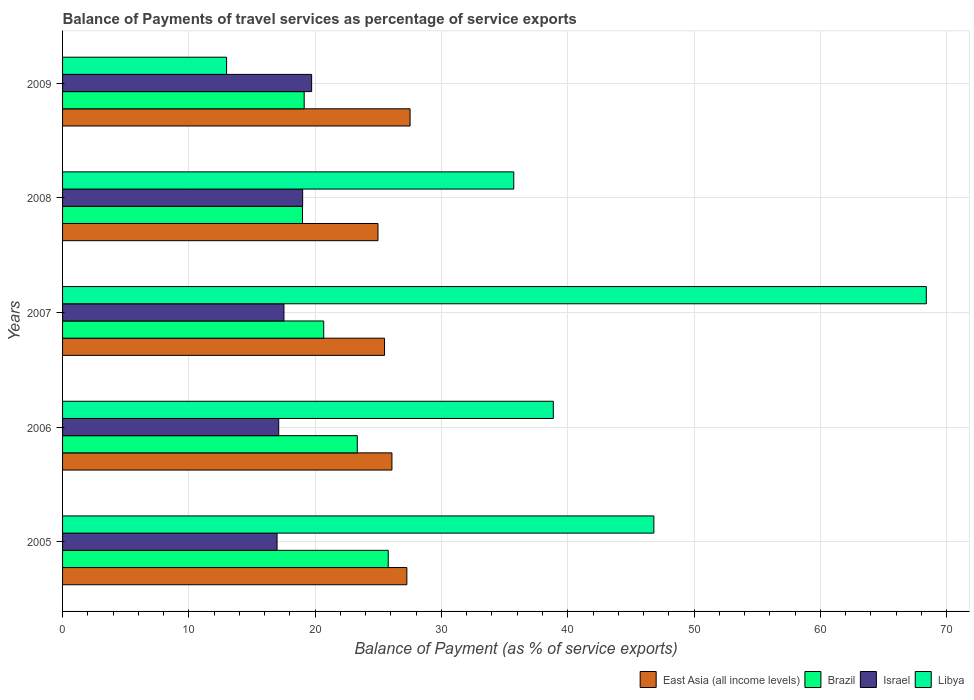How many different coloured bars are there?
Give a very brief answer. 4. How many groups of bars are there?
Provide a succinct answer. 5. Are the number of bars per tick equal to the number of legend labels?
Make the answer very short. Yes. How many bars are there on the 2nd tick from the top?
Ensure brevity in your answer.  4. How many bars are there on the 2nd tick from the bottom?
Offer a very short reply. 4. What is the label of the 2nd group of bars from the top?
Offer a terse response. 2008. In how many cases, is the number of bars for a given year not equal to the number of legend labels?
Offer a terse response. 0. What is the balance of payments of travel services in Brazil in 2007?
Make the answer very short. 20.68. Across all years, what is the maximum balance of payments of travel services in Libya?
Keep it short and to the point. 68.39. Across all years, what is the minimum balance of payments of travel services in Israel?
Your answer should be very brief. 16.98. What is the total balance of payments of travel services in Libya in the graph?
Your answer should be very brief. 202.77. What is the difference between the balance of payments of travel services in Israel in 2005 and that in 2009?
Provide a short and direct response. -2.74. What is the difference between the balance of payments of travel services in Israel in 2006 and the balance of payments of travel services in East Asia (all income levels) in 2009?
Provide a short and direct response. -10.4. What is the average balance of payments of travel services in Israel per year?
Make the answer very short. 18.07. In the year 2009, what is the difference between the balance of payments of travel services in East Asia (all income levels) and balance of payments of travel services in Israel?
Ensure brevity in your answer.  7.79. What is the ratio of the balance of payments of travel services in Israel in 2008 to that in 2009?
Offer a terse response. 0.96. Is the balance of payments of travel services in Libya in 2006 less than that in 2009?
Provide a short and direct response. No. What is the difference between the highest and the second highest balance of payments of travel services in East Asia (all income levels)?
Offer a very short reply. 0.25. What is the difference between the highest and the lowest balance of payments of travel services in Libya?
Keep it short and to the point. 55.4. In how many years, is the balance of payments of travel services in Israel greater than the average balance of payments of travel services in Israel taken over all years?
Provide a short and direct response. 2. Is the sum of the balance of payments of travel services in Libya in 2008 and 2009 greater than the maximum balance of payments of travel services in Israel across all years?
Your answer should be very brief. Yes. What does the 2nd bar from the top in 2007 represents?
Offer a very short reply. Israel. What does the 3rd bar from the bottom in 2008 represents?
Give a very brief answer. Israel. Is it the case that in every year, the sum of the balance of payments of travel services in Israel and balance of payments of travel services in Brazil is greater than the balance of payments of travel services in Libya?
Provide a succinct answer. No. Does the graph contain grids?
Make the answer very short. Yes. How many legend labels are there?
Offer a very short reply. 4. How are the legend labels stacked?
Offer a very short reply. Horizontal. What is the title of the graph?
Your answer should be compact. Balance of Payments of travel services as percentage of service exports. Does "Heavily indebted poor countries" appear as one of the legend labels in the graph?
Make the answer very short. No. What is the label or title of the X-axis?
Your answer should be compact. Balance of Payment (as % of service exports). What is the Balance of Payment (as % of service exports) of East Asia (all income levels) in 2005?
Offer a terse response. 27.26. What is the Balance of Payment (as % of service exports) of Brazil in 2005?
Provide a short and direct response. 25.78. What is the Balance of Payment (as % of service exports) of Israel in 2005?
Provide a short and direct response. 16.98. What is the Balance of Payment (as % of service exports) in Libya in 2005?
Your answer should be very brief. 46.82. What is the Balance of Payment (as % of service exports) in East Asia (all income levels) in 2006?
Provide a succinct answer. 26.08. What is the Balance of Payment (as % of service exports) of Brazil in 2006?
Ensure brevity in your answer.  23.34. What is the Balance of Payment (as % of service exports) in Israel in 2006?
Provide a short and direct response. 17.11. What is the Balance of Payment (as % of service exports) in Libya in 2006?
Offer a terse response. 38.85. What is the Balance of Payment (as % of service exports) in East Asia (all income levels) in 2007?
Offer a very short reply. 25.49. What is the Balance of Payment (as % of service exports) in Brazil in 2007?
Your answer should be very brief. 20.68. What is the Balance of Payment (as % of service exports) of Israel in 2007?
Your response must be concise. 17.53. What is the Balance of Payment (as % of service exports) in Libya in 2007?
Keep it short and to the point. 68.39. What is the Balance of Payment (as % of service exports) of East Asia (all income levels) in 2008?
Your response must be concise. 24.97. What is the Balance of Payment (as % of service exports) in Brazil in 2008?
Your answer should be very brief. 19. What is the Balance of Payment (as % of service exports) in Israel in 2008?
Your answer should be very brief. 19.01. What is the Balance of Payment (as % of service exports) in Libya in 2008?
Make the answer very short. 35.72. What is the Balance of Payment (as % of service exports) of East Asia (all income levels) in 2009?
Provide a short and direct response. 27.51. What is the Balance of Payment (as % of service exports) of Brazil in 2009?
Make the answer very short. 19.13. What is the Balance of Payment (as % of service exports) in Israel in 2009?
Provide a succinct answer. 19.72. What is the Balance of Payment (as % of service exports) in Libya in 2009?
Provide a short and direct response. 12.99. Across all years, what is the maximum Balance of Payment (as % of service exports) in East Asia (all income levels)?
Offer a very short reply. 27.51. Across all years, what is the maximum Balance of Payment (as % of service exports) of Brazil?
Provide a succinct answer. 25.78. Across all years, what is the maximum Balance of Payment (as % of service exports) of Israel?
Your answer should be compact. 19.72. Across all years, what is the maximum Balance of Payment (as % of service exports) in Libya?
Offer a terse response. 68.39. Across all years, what is the minimum Balance of Payment (as % of service exports) of East Asia (all income levels)?
Keep it short and to the point. 24.97. Across all years, what is the minimum Balance of Payment (as % of service exports) of Brazil?
Provide a short and direct response. 19. Across all years, what is the minimum Balance of Payment (as % of service exports) in Israel?
Give a very brief answer. 16.98. Across all years, what is the minimum Balance of Payment (as % of service exports) in Libya?
Provide a short and direct response. 12.99. What is the total Balance of Payment (as % of service exports) in East Asia (all income levels) in the graph?
Provide a short and direct response. 131.32. What is the total Balance of Payment (as % of service exports) in Brazil in the graph?
Make the answer very short. 107.93. What is the total Balance of Payment (as % of service exports) of Israel in the graph?
Provide a succinct answer. 90.35. What is the total Balance of Payment (as % of service exports) in Libya in the graph?
Keep it short and to the point. 202.77. What is the difference between the Balance of Payment (as % of service exports) of East Asia (all income levels) in 2005 and that in 2006?
Your response must be concise. 1.18. What is the difference between the Balance of Payment (as % of service exports) in Brazil in 2005 and that in 2006?
Offer a very short reply. 2.45. What is the difference between the Balance of Payment (as % of service exports) of Israel in 2005 and that in 2006?
Offer a terse response. -0.13. What is the difference between the Balance of Payment (as % of service exports) in Libya in 2005 and that in 2006?
Give a very brief answer. 7.96. What is the difference between the Balance of Payment (as % of service exports) in East Asia (all income levels) in 2005 and that in 2007?
Provide a short and direct response. 1.77. What is the difference between the Balance of Payment (as % of service exports) of Brazil in 2005 and that in 2007?
Provide a short and direct response. 5.11. What is the difference between the Balance of Payment (as % of service exports) of Israel in 2005 and that in 2007?
Your response must be concise. -0.55. What is the difference between the Balance of Payment (as % of service exports) of Libya in 2005 and that in 2007?
Your response must be concise. -21.57. What is the difference between the Balance of Payment (as % of service exports) of East Asia (all income levels) in 2005 and that in 2008?
Your response must be concise. 2.29. What is the difference between the Balance of Payment (as % of service exports) of Brazil in 2005 and that in 2008?
Your answer should be compact. 6.79. What is the difference between the Balance of Payment (as % of service exports) of Israel in 2005 and that in 2008?
Your answer should be compact. -2.03. What is the difference between the Balance of Payment (as % of service exports) of Libya in 2005 and that in 2008?
Make the answer very short. 11.09. What is the difference between the Balance of Payment (as % of service exports) of East Asia (all income levels) in 2005 and that in 2009?
Ensure brevity in your answer.  -0.25. What is the difference between the Balance of Payment (as % of service exports) in Brazil in 2005 and that in 2009?
Offer a very short reply. 6.65. What is the difference between the Balance of Payment (as % of service exports) in Israel in 2005 and that in 2009?
Give a very brief answer. -2.74. What is the difference between the Balance of Payment (as % of service exports) of Libya in 2005 and that in 2009?
Ensure brevity in your answer.  33.83. What is the difference between the Balance of Payment (as % of service exports) of East Asia (all income levels) in 2006 and that in 2007?
Provide a short and direct response. 0.59. What is the difference between the Balance of Payment (as % of service exports) of Brazil in 2006 and that in 2007?
Make the answer very short. 2.66. What is the difference between the Balance of Payment (as % of service exports) in Israel in 2006 and that in 2007?
Keep it short and to the point. -0.42. What is the difference between the Balance of Payment (as % of service exports) in Libya in 2006 and that in 2007?
Provide a succinct answer. -29.53. What is the difference between the Balance of Payment (as % of service exports) of East Asia (all income levels) in 2006 and that in 2008?
Give a very brief answer. 1.1. What is the difference between the Balance of Payment (as % of service exports) of Brazil in 2006 and that in 2008?
Your answer should be compact. 4.34. What is the difference between the Balance of Payment (as % of service exports) in Israel in 2006 and that in 2008?
Your answer should be compact. -1.9. What is the difference between the Balance of Payment (as % of service exports) in Libya in 2006 and that in 2008?
Give a very brief answer. 3.13. What is the difference between the Balance of Payment (as % of service exports) of East Asia (all income levels) in 2006 and that in 2009?
Provide a short and direct response. -1.44. What is the difference between the Balance of Payment (as % of service exports) in Brazil in 2006 and that in 2009?
Ensure brevity in your answer.  4.2. What is the difference between the Balance of Payment (as % of service exports) in Israel in 2006 and that in 2009?
Ensure brevity in your answer.  -2.61. What is the difference between the Balance of Payment (as % of service exports) in Libya in 2006 and that in 2009?
Provide a short and direct response. 25.87. What is the difference between the Balance of Payment (as % of service exports) in East Asia (all income levels) in 2007 and that in 2008?
Your answer should be compact. 0.52. What is the difference between the Balance of Payment (as % of service exports) in Brazil in 2007 and that in 2008?
Provide a succinct answer. 1.68. What is the difference between the Balance of Payment (as % of service exports) in Israel in 2007 and that in 2008?
Keep it short and to the point. -1.48. What is the difference between the Balance of Payment (as % of service exports) in Libya in 2007 and that in 2008?
Provide a short and direct response. 32.66. What is the difference between the Balance of Payment (as % of service exports) in East Asia (all income levels) in 2007 and that in 2009?
Your answer should be compact. -2.02. What is the difference between the Balance of Payment (as % of service exports) in Brazil in 2007 and that in 2009?
Ensure brevity in your answer.  1.55. What is the difference between the Balance of Payment (as % of service exports) of Israel in 2007 and that in 2009?
Your answer should be very brief. -2.19. What is the difference between the Balance of Payment (as % of service exports) of Libya in 2007 and that in 2009?
Your answer should be compact. 55.4. What is the difference between the Balance of Payment (as % of service exports) of East Asia (all income levels) in 2008 and that in 2009?
Your answer should be very brief. -2.54. What is the difference between the Balance of Payment (as % of service exports) of Brazil in 2008 and that in 2009?
Offer a very short reply. -0.13. What is the difference between the Balance of Payment (as % of service exports) in Israel in 2008 and that in 2009?
Your response must be concise. -0.71. What is the difference between the Balance of Payment (as % of service exports) in Libya in 2008 and that in 2009?
Provide a short and direct response. 22.74. What is the difference between the Balance of Payment (as % of service exports) in East Asia (all income levels) in 2005 and the Balance of Payment (as % of service exports) in Brazil in 2006?
Give a very brief answer. 3.92. What is the difference between the Balance of Payment (as % of service exports) in East Asia (all income levels) in 2005 and the Balance of Payment (as % of service exports) in Israel in 2006?
Keep it short and to the point. 10.15. What is the difference between the Balance of Payment (as % of service exports) in East Asia (all income levels) in 2005 and the Balance of Payment (as % of service exports) in Libya in 2006?
Your response must be concise. -11.59. What is the difference between the Balance of Payment (as % of service exports) of Brazil in 2005 and the Balance of Payment (as % of service exports) of Israel in 2006?
Keep it short and to the point. 8.67. What is the difference between the Balance of Payment (as % of service exports) in Brazil in 2005 and the Balance of Payment (as % of service exports) in Libya in 2006?
Your answer should be compact. -13.07. What is the difference between the Balance of Payment (as % of service exports) in Israel in 2005 and the Balance of Payment (as % of service exports) in Libya in 2006?
Ensure brevity in your answer.  -21.87. What is the difference between the Balance of Payment (as % of service exports) of East Asia (all income levels) in 2005 and the Balance of Payment (as % of service exports) of Brazil in 2007?
Make the answer very short. 6.58. What is the difference between the Balance of Payment (as % of service exports) in East Asia (all income levels) in 2005 and the Balance of Payment (as % of service exports) in Israel in 2007?
Provide a short and direct response. 9.73. What is the difference between the Balance of Payment (as % of service exports) in East Asia (all income levels) in 2005 and the Balance of Payment (as % of service exports) in Libya in 2007?
Provide a succinct answer. -41.13. What is the difference between the Balance of Payment (as % of service exports) of Brazil in 2005 and the Balance of Payment (as % of service exports) of Israel in 2007?
Offer a terse response. 8.26. What is the difference between the Balance of Payment (as % of service exports) of Brazil in 2005 and the Balance of Payment (as % of service exports) of Libya in 2007?
Ensure brevity in your answer.  -42.6. What is the difference between the Balance of Payment (as % of service exports) in Israel in 2005 and the Balance of Payment (as % of service exports) in Libya in 2007?
Your answer should be very brief. -51.4. What is the difference between the Balance of Payment (as % of service exports) of East Asia (all income levels) in 2005 and the Balance of Payment (as % of service exports) of Brazil in 2008?
Give a very brief answer. 8.26. What is the difference between the Balance of Payment (as % of service exports) in East Asia (all income levels) in 2005 and the Balance of Payment (as % of service exports) in Israel in 2008?
Provide a succinct answer. 8.25. What is the difference between the Balance of Payment (as % of service exports) in East Asia (all income levels) in 2005 and the Balance of Payment (as % of service exports) in Libya in 2008?
Make the answer very short. -8.46. What is the difference between the Balance of Payment (as % of service exports) in Brazil in 2005 and the Balance of Payment (as % of service exports) in Israel in 2008?
Give a very brief answer. 6.78. What is the difference between the Balance of Payment (as % of service exports) in Brazil in 2005 and the Balance of Payment (as % of service exports) in Libya in 2008?
Your response must be concise. -9.94. What is the difference between the Balance of Payment (as % of service exports) in Israel in 2005 and the Balance of Payment (as % of service exports) in Libya in 2008?
Provide a succinct answer. -18.74. What is the difference between the Balance of Payment (as % of service exports) in East Asia (all income levels) in 2005 and the Balance of Payment (as % of service exports) in Brazil in 2009?
Your response must be concise. 8.13. What is the difference between the Balance of Payment (as % of service exports) in East Asia (all income levels) in 2005 and the Balance of Payment (as % of service exports) in Israel in 2009?
Provide a succinct answer. 7.54. What is the difference between the Balance of Payment (as % of service exports) of East Asia (all income levels) in 2005 and the Balance of Payment (as % of service exports) of Libya in 2009?
Your answer should be compact. 14.27. What is the difference between the Balance of Payment (as % of service exports) in Brazil in 2005 and the Balance of Payment (as % of service exports) in Israel in 2009?
Provide a succinct answer. 6.06. What is the difference between the Balance of Payment (as % of service exports) in Brazil in 2005 and the Balance of Payment (as % of service exports) in Libya in 2009?
Make the answer very short. 12.8. What is the difference between the Balance of Payment (as % of service exports) in Israel in 2005 and the Balance of Payment (as % of service exports) in Libya in 2009?
Your answer should be compact. 4. What is the difference between the Balance of Payment (as % of service exports) of East Asia (all income levels) in 2006 and the Balance of Payment (as % of service exports) of Brazil in 2007?
Make the answer very short. 5.4. What is the difference between the Balance of Payment (as % of service exports) of East Asia (all income levels) in 2006 and the Balance of Payment (as % of service exports) of Israel in 2007?
Your answer should be very brief. 8.55. What is the difference between the Balance of Payment (as % of service exports) in East Asia (all income levels) in 2006 and the Balance of Payment (as % of service exports) in Libya in 2007?
Provide a succinct answer. -42.31. What is the difference between the Balance of Payment (as % of service exports) in Brazil in 2006 and the Balance of Payment (as % of service exports) in Israel in 2007?
Offer a terse response. 5.81. What is the difference between the Balance of Payment (as % of service exports) of Brazil in 2006 and the Balance of Payment (as % of service exports) of Libya in 2007?
Make the answer very short. -45.05. What is the difference between the Balance of Payment (as % of service exports) in Israel in 2006 and the Balance of Payment (as % of service exports) in Libya in 2007?
Your answer should be compact. -51.27. What is the difference between the Balance of Payment (as % of service exports) of East Asia (all income levels) in 2006 and the Balance of Payment (as % of service exports) of Brazil in 2008?
Offer a terse response. 7.08. What is the difference between the Balance of Payment (as % of service exports) of East Asia (all income levels) in 2006 and the Balance of Payment (as % of service exports) of Israel in 2008?
Ensure brevity in your answer.  7.07. What is the difference between the Balance of Payment (as % of service exports) of East Asia (all income levels) in 2006 and the Balance of Payment (as % of service exports) of Libya in 2008?
Give a very brief answer. -9.65. What is the difference between the Balance of Payment (as % of service exports) in Brazil in 2006 and the Balance of Payment (as % of service exports) in Israel in 2008?
Provide a succinct answer. 4.33. What is the difference between the Balance of Payment (as % of service exports) of Brazil in 2006 and the Balance of Payment (as % of service exports) of Libya in 2008?
Your answer should be compact. -12.39. What is the difference between the Balance of Payment (as % of service exports) of Israel in 2006 and the Balance of Payment (as % of service exports) of Libya in 2008?
Your answer should be very brief. -18.61. What is the difference between the Balance of Payment (as % of service exports) in East Asia (all income levels) in 2006 and the Balance of Payment (as % of service exports) in Brazil in 2009?
Offer a terse response. 6.95. What is the difference between the Balance of Payment (as % of service exports) of East Asia (all income levels) in 2006 and the Balance of Payment (as % of service exports) of Israel in 2009?
Your response must be concise. 6.36. What is the difference between the Balance of Payment (as % of service exports) in East Asia (all income levels) in 2006 and the Balance of Payment (as % of service exports) in Libya in 2009?
Provide a succinct answer. 13.09. What is the difference between the Balance of Payment (as % of service exports) in Brazil in 2006 and the Balance of Payment (as % of service exports) in Israel in 2009?
Your response must be concise. 3.61. What is the difference between the Balance of Payment (as % of service exports) in Brazil in 2006 and the Balance of Payment (as % of service exports) in Libya in 2009?
Make the answer very short. 10.35. What is the difference between the Balance of Payment (as % of service exports) in Israel in 2006 and the Balance of Payment (as % of service exports) in Libya in 2009?
Your response must be concise. 4.13. What is the difference between the Balance of Payment (as % of service exports) of East Asia (all income levels) in 2007 and the Balance of Payment (as % of service exports) of Brazil in 2008?
Your response must be concise. 6.49. What is the difference between the Balance of Payment (as % of service exports) in East Asia (all income levels) in 2007 and the Balance of Payment (as % of service exports) in Israel in 2008?
Provide a succinct answer. 6.48. What is the difference between the Balance of Payment (as % of service exports) of East Asia (all income levels) in 2007 and the Balance of Payment (as % of service exports) of Libya in 2008?
Provide a succinct answer. -10.23. What is the difference between the Balance of Payment (as % of service exports) in Brazil in 2007 and the Balance of Payment (as % of service exports) in Israel in 2008?
Provide a short and direct response. 1.67. What is the difference between the Balance of Payment (as % of service exports) in Brazil in 2007 and the Balance of Payment (as % of service exports) in Libya in 2008?
Make the answer very short. -15.05. What is the difference between the Balance of Payment (as % of service exports) of Israel in 2007 and the Balance of Payment (as % of service exports) of Libya in 2008?
Offer a very short reply. -18.2. What is the difference between the Balance of Payment (as % of service exports) of East Asia (all income levels) in 2007 and the Balance of Payment (as % of service exports) of Brazil in 2009?
Provide a succinct answer. 6.36. What is the difference between the Balance of Payment (as % of service exports) in East Asia (all income levels) in 2007 and the Balance of Payment (as % of service exports) in Israel in 2009?
Make the answer very short. 5.77. What is the difference between the Balance of Payment (as % of service exports) in East Asia (all income levels) in 2007 and the Balance of Payment (as % of service exports) in Libya in 2009?
Your answer should be compact. 12.5. What is the difference between the Balance of Payment (as % of service exports) in Brazil in 2007 and the Balance of Payment (as % of service exports) in Israel in 2009?
Your answer should be compact. 0.96. What is the difference between the Balance of Payment (as % of service exports) in Brazil in 2007 and the Balance of Payment (as % of service exports) in Libya in 2009?
Provide a short and direct response. 7.69. What is the difference between the Balance of Payment (as % of service exports) of Israel in 2007 and the Balance of Payment (as % of service exports) of Libya in 2009?
Your response must be concise. 4.54. What is the difference between the Balance of Payment (as % of service exports) in East Asia (all income levels) in 2008 and the Balance of Payment (as % of service exports) in Brazil in 2009?
Offer a terse response. 5.84. What is the difference between the Balance of Payment (as % of service exports) of East Asia (all income levels) in 2008 and the Balance of Payment (as % of service exports) of Israel in 2009?
Offer a very short reply. 5.25. What is the difference between the Balance of Payment (as % of service exports) of East Asia (all income levels) in 2008 and the Balance of Payment (as % of service exports) of Libya in 2009?
Keep it short and to the point. 11.99. What is the difference between the Balance of Payment (as % of service exports) in Brazil in 2008 and the Balance of Payment (as % of service exports) in Israel in 2009?
Offer a very short reply. -0.72. What is the difference between the Balance of Payment (as % of service exports) in Brazil in 2008 and the Balance of Payment (as % of service exports) in Libya in 2009?
Offer a very short reply. 6.01. What is the difference between the Balance of Payment (as % of service exports) in Israel in 2008 and the Balance of Payment (as % of service exports) in Libya in 2009?
Give a very brief answer. 6.02. What is the average Balance of Payment (as % of service exports) in East Asia (all income levels) per year?
Keep it short and to the point. 26.26. What is the average Balance of Payment (as % of service exports) in Brazil per year?
Your response must be concise. 21.59. What is the average Balance of Payment (as % of service exports) of Israel per year?
Provide a short and direct response. 18.07. What is the average Balance of Payment (as % of service exports) of Libya per year?
Offer a very short reply. 40.55. In the year 2005, what is the difference between the Balance of Payment (as % of service exports) in East Asia (all income levels) and Balance of Payment (as % of service exports) in Brazil?
Offer a terse response. 1.48. In the year 2005, what is the difference between the Balance of Payment (as % of service exports) in East Asia (all income levels) and Balance of Payment (as % of service exports) in Israel?
Offer a terse response. 10.28. In the year 2005, what is the difference between the Balance of Payment (as % of service exports) in East Asia (all income levels) and Balance of Payment (as % of service exports) in Libya?
Keep it short and to the point. -19.56. In the year 2005, what is the difference between the Balance of Payment (as % of service exports) of Brazil and Balance of Payment (as % of service exports) of Israel?
Ensure brevity in your answer.  8.8. In the year 2005, what is the difference between the Balance of Payment (as % of service exports) of Brazil and Balance of Payment (as % of service exports) of Libya?
Make the answer very short. -21.03. In the year 2005, what is the difference between the Balance of Payment (as % of service exports) of Israel and Balance of Payment (as % of service exports) of Libya?
Make the answer very short. -29.83. In the year 2006, what is the difference between the Balance of Payment (as % of service exports) of East Asia (all income levels) and Balance of Payment (as % of service exports) of Brazil?
Offer a terse response. 2.74. In the year 2006, what is the difference between the Balance of Payment (as % of service exports) of East Asia (all income levels) and Balance of Payment (as % of service exports) of Israel?
Offer a very short reply. 8.97. In the year 2006, what is the difference between the Balance of Payment (as % of service exports) in East Asia (all income levels) and Balance of Payment (as % of service exports) in Libya?
Offer a terse response. -12.78. In the year 2006, what is the difference between the Balance of Payment (as % of service exports) in Brazil and Balance of Payment (as % of service exports) in Israel?
Offer a terse response. 6.22. In the year 2006, what is the difference between the Balance of Payment (as % of service exports) of Brazil and Balance of Payment (as % of service exports) of Libya?
Your answer should be very brief. -15.52. In the year 2006, what is the difference between the Balance of Payment (as % of service exports) of Israel and Balance of Payment (as % of service exports) of Libya?
Keep it short and to the point. -21.74. In the year 2007, what is the difference between the Balance of Payment (as % of service exports) in East Asia (all income levels) and Balance of Payment (as % of service exports) in Brazil?
Make the answer very short. 4.81. In the year 2007, what is the difference between the Balance of Payment (as % of service exports) in East Asia (all income levels) and Balance of Payment (as % of service exports) in Israel?
Offer a very short reply. 7.96. In the year 2007, what is the difference between the Balance of Payment (as % of service exports) of East Asia (all income levels) and Balance of Payment (as % of service exports) of Libya?
Your answer should be very brief. -42.9. In the year 2007, what is the difference between the Balance of Payment (as % of service exports) in Brazil and Balance of Payment (as % of service exports) in Israel?
Provide a short and direct response. 3.15. In the year 2007, what is the difference between the Balance of Payment (as % of service exports) in Brazil and Balance of Payment (as % of service exports) in Libya?
Your answer should be compact. -47.71. In the year 2007, what is the difference between the Balance of Payment (as % of service exports) of Israel and Balance of Payment (as % of service exports) of Libya?
Give a very brief answer. -50.86. In the year 2008, what is the difference between the Balance of Payment (as % of service exports) of East Asia (all income levels) and Balance of Payment (as % of service exports) of Brazil?
Your answer should be compact. 5.98. In the year 2008, what is the difference between the Balance of Payment (as % of service exports) in East Asia (all income levels) and Balance of Payment (as % of service exports) in Israel?
Your answer should be very brief. 5.96. In the year 2008, what is the difference between the Balance of Payment (as % of service exports) of East Asia (all income levels) and Balance of Payment (as % of service exports) of Libya?
Give a very brief answer. -10.75. In the year 2008, what is the difference between the Balance of Payment (as % of service exports) of Brazil and Balance of Payment (as % of service exports) of Israel?
Make the answer very short. -0.01. In the year 2008, what is the difference between the Balance of Payment (as % of service exports) of Brazil and Balance of Payment (as % of service exports) of Libya?
Offer a very short reply. -16.73. In the year 2008, what is the difference between the Balance of Payment (as % of service exports) in Israel and Balance of Payment (as % of service exports) in Libya?
Keep it short and to the point. -16.72. In the year 2009, what is the difference between the Balance of Payment (as % of service exports) of East Asia (all income levels) and Balance of Payment (as % of service exports) of Brazil?
Ensure brevity in your answer.  8.38. In the year 2009, what is the difference between the Balance of Payment (as % of service exports) in East Asia (all income levels) and Balance of Payment (as % of service exports) in Israel?
Keep it short and to the point. 7.79. In the year 2009, what is the difference between the Balance of Payment (as % of service exports) in East Asia (all income levels) and Balance of Payment (as % of service exports) in Libya?
Your response must be concise. 14.53. In the year 2009, what is the difference between the Balance of Payment (as % of service exports) in Brazil and Balance of Payment (as % of service exports) in Israel?
Your answer should be compact. -0.59. In the year 2009, what is the difference between the Balance of Payment (as % of service exports) in Brazil and Balance of Payment (as % of service exports) in Libya?
Offer a very short reply. 6.14. In the year 2009, what is the difference between the Balance of Payment (as % of service exports) of Israel and Balance of Payment (as % of service exports) of Libya?
Offer a terse response. 6.73. What is the ratio of the Balance of Payment (as % of service exports) in East Asia (all income levels) in 2005 to that in 2006?
Provide a short and direct response. 1.05. What is the ratio of the Balance of Payment (as % of service exports) of Brazil in 2005 to that in 2006?
Your response must be concise. 1.1. What is the ratio of the Balance of Payment (as % of service exports) of Israel in 2005 to that in 2006?
Your answer should be very brief. 0.99. What is the ratio of the Balance of Payment (as % of service exports) of Libya in 2005 to that in 2006?
Keep it short and to the point. 1.2. What is the ratio of the Balance of Payment (as % of service exports) in East Asia (all income levels) in 2005 to that in 2007?
Provide a succinct answer. 1.07. What is the ratio of the Balance of Payment (as % of service exports) of Brazil in 2005 to that in 2007?
Make the answer very short. 1.25. What is the ratio of the Balance of Payment (as % of service exports) of Israel in 2005 to that in 2007?
Keep it short and to the point. 0.97. What is the ratio of the Balance of Payment (as % of service exports) of Libya in 2005 to that in 2007?
Keep it short and to the point. 0.68. What is the ratio of the Balance of Payment (as % of service exports) of East Asia (all income levels) in 2005 to that in 2008?
Your response must be concise. 1.09. What is the ratio of the Balance of Payment (as % of service exports) of Brazil in 2005 to that in 2008?
Offer a terse response. 1.36. What is the ratio of the Balance of Payment (as % of service exports) of Israel in 2005 to that in 2008?
Keep it short and to the point. 0.89. What is the ratio of the Balance of Payment (as % of service exports) of Libya in 2005 to that in 2008?
Offer a very short reply. 1.31. What is the ratio of the Balance of Payment (as % of service exports) of East Asia (all income levels) in 2005 to that in 2009?
Offer a terse response. 0.99. What is the ratio of the Balance of Payment (as % of service exports) of Brazil in 2005 to that in 2009?
Your answer should be compact. 1.35. What is the ratio of the Balance of Payment (as % of service exports) of Israel in 2005 to that in 2009?
Your answer should be compact. 0.86. What is the ratio of the Balance of Payment (as % of service exports) of Libya in 2005 to that in 2009?
Make the answer very short. 3.6. What is the ratio of the Balance of Payment (as % of service exports) in Brazil in 2006 to that in 2007?
Keep it short and to the point. 1.13. What is the ratio of the Balance of Payment (as % of service exports) in Israel in 2006 to that in 2007?
Provide a succinct answer. 0.98. What is the ratio of the Balance of Payment (as % of service exports) in Libya in 2006 to that in 2007?
Offer a very short reply. 0.57. What is the ratio of the Balance of Payment (as % of service exports) in East Asia (all income levels) in 2006 to that in 2008?
Your answer should be compact. 1.04. What is the ratio of the Balance of Payment (as % of service exports) in Brazil in 2006 to that in 2008?
Your answer should be compact. 1.23. What is the ratio of the Balance of Payment (as % of service exports) in Israel in 2006 to that in 2008?
Offer a terse response. 0.9. What is the ratio of the Balance of Payment (as % of service exports) of Libya in 2006 to that in 2008?
Ensure brevity in your answer.  1.09. What is the ratio of the Balance of Payment (as % of service exports) in East Asia (all income levels) in 2006 to that in 2009?
Make the answer very short. 0.95. What is the ratio of the Balance of Payment (as % of service exports) in Brazil in 2006 to that in 2009?
Make the answer very short. 1.22. What is the ratio of the Balance of Payment (as % of service exports) of Israel in 2006 to that in 2009?
Give a very brief answer. 0.87. What is the ratio of the Balance of Payment (as % of service exports) of Libya in 2006 to that in 2009?
Provide a short and direct response. 2.99. What is the ratio of the Balance of Payment (as % of service exports) of East Asia (all income levels) in 2007 to that in 2008?
Provide a succinct answer. 1.02. What is the ratio of the Balance of Payment (as % of service exports) of Brazil in 2007 to that in 2008?
Give a very brief answer. 1.09. What is the ratio of the Balance of Payment (as % of service exports) of Israel in 2007 to that in 2008?
Provide a short and direct response. 0.92. What is the ratio of the Balance of Payment (as % of service exports) of Libya in 2007 to that in 2008?
Give a very brief answer. 1.91. What is the ratio of the Balance of Payment (as % of service exports) of East Asia (all income levels) in 2007 to that in 2009?
Keep it short and to the point. 0.93. What is the ratio of the Balance of Payment (as % of service exports) of Brazil in 2007 to that in 2009?
Your answer should be compact. 1.08. What is the ratio of the Balance of Payment (as % of service exports) in Israel in 2007 to that in 2009?
Keep it short and to the point. 0.89. What is the ratio of the Balance of Payment (as % of service exports) of Libya in 2007 to that in 2009?
Provide a short and direct response. 5.27. What is the ratio of the Balance of Payment (as % of service exports) of East Asia (all income levels) in 2008 to that in 2009?
Make the answer very short. 0.91. What is the ratio of the Balance of Payment (as % of service exports) of Israel in 2008 to that in 2009?
Give a very brief answer. 0.96. What is the ratio of the Balance of Payment (as % of service exports) in Libya in 2008 to that in 2009?
Ensure brevity in your answer.  2.75. What is the difference between the highest and the second highest Balance of Payment (as % of service exports) in East Asia (all income levels)?
Make the answer very short. 0.25. What is the difference between the highest and the second highest Balance of Payment (as % of service exports) in Brazil?
Your answer should be compact. 2.45. What is the difference between the highest and the second highest Balance of Payment (as % of service exports) in Israel?
Give a very brief answer. 0.71. What is the difference between the highest and the second highest Balance of Payment (as % of service exports) in Libya?
Your response must be concise. 21.57. What is the difference between the highest and the lowest Balance of Payment (as % of service exports) of East Asia (all income levels)?
Offer a terse response. 2.54. What is the difference between the highest and the lowest Balance of Payment (as % of service exports) in Brazil?
Make the answer very short. 6.79. What is the difference between the highest and the lowest Balance of Payment (as % of service exports) in Israel?
Offer a very short reply. 2.74. What is the difference between the highest and the lowest Balance of Payment (as % of service exports) in Libya?
Your response must be concise. 55.4. 